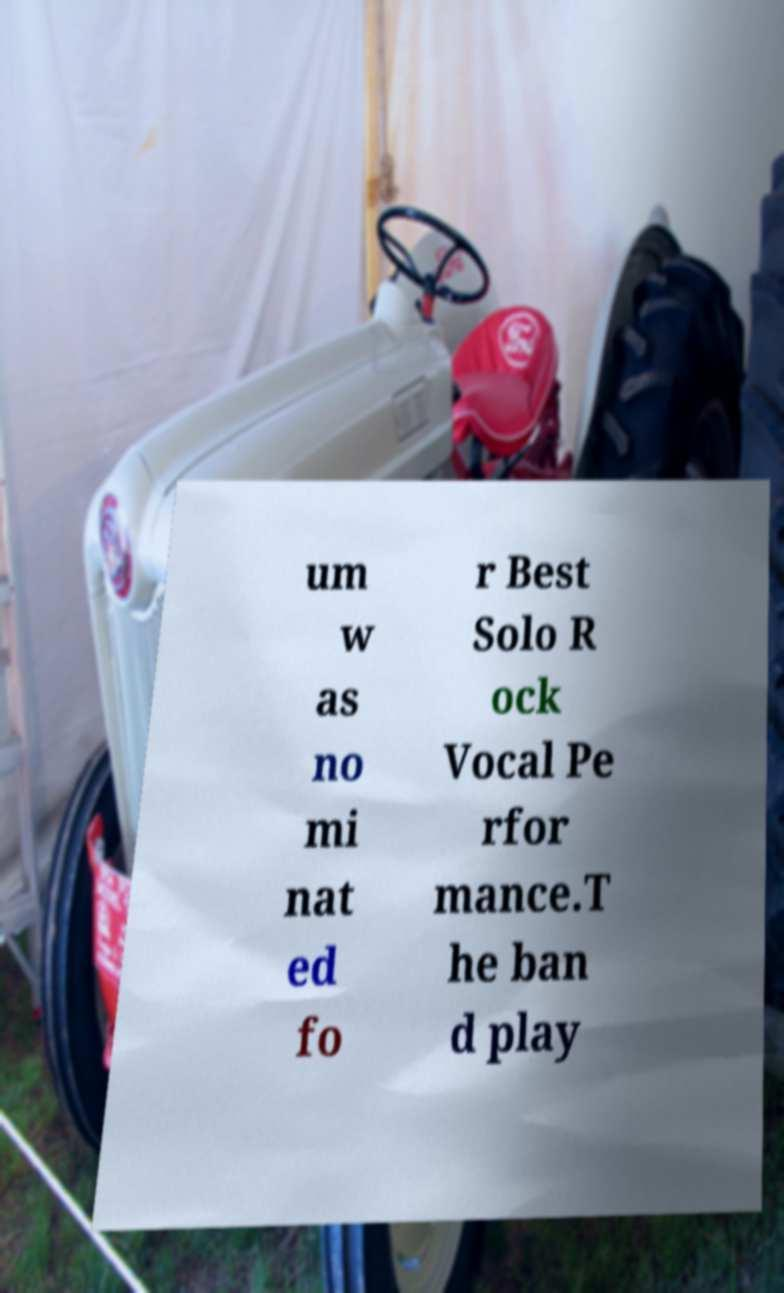Can you read and provide the text displayed in the image?This photo seems to have some interesting text. Can you extract and type it out for me? um w as no mi nat ed fo r Best Solo R ock Vocal Pe rfor mance.T he ban d play 